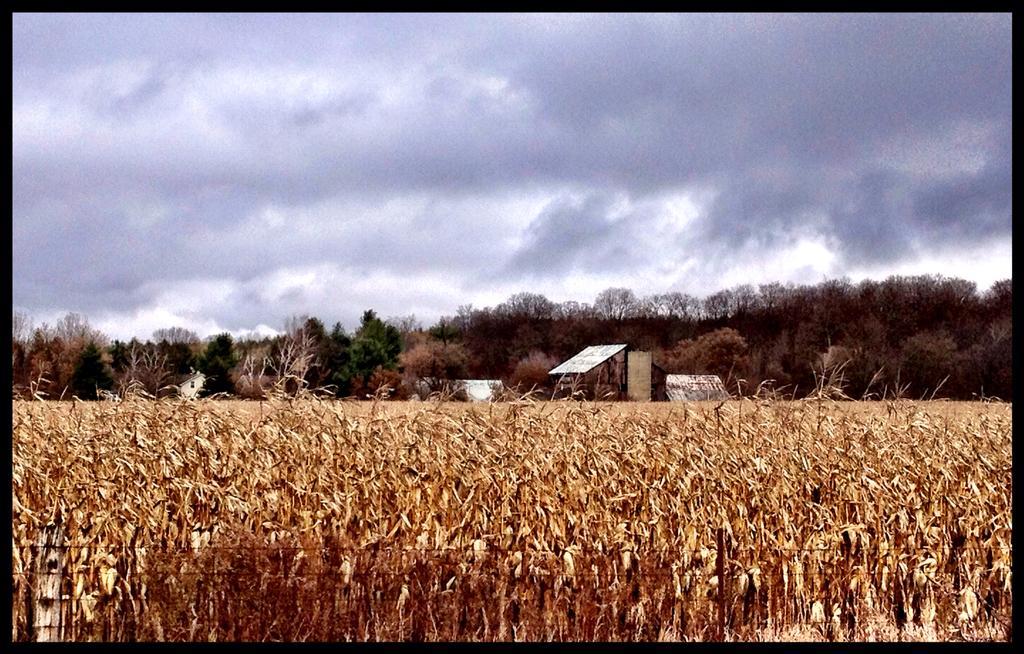Describe this image in one or two sentences. This is an edited image. This image has borders. In the center of the image there is crop. In the background of the image there are trees. At the top of the image there is sky and clouds. 